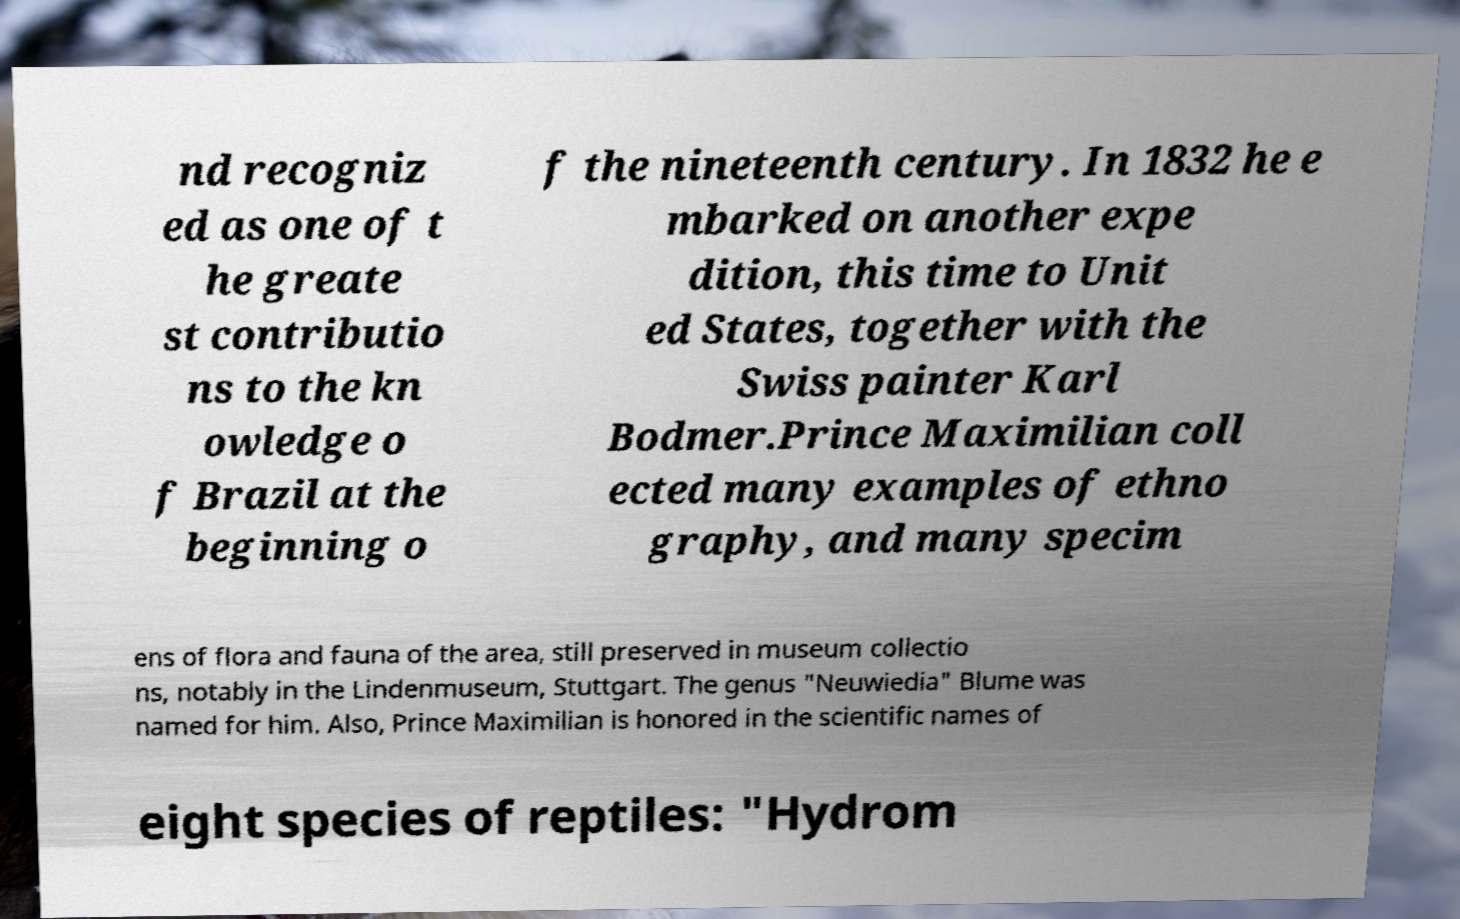There's text embedded in this image that I need extracted. Can you transcribe it verbatim? nd recogniz ed as one of t he greate st contributio ns to the kn owledge o f Brazil at the beginning o f the nineteenth century. In 1832 he e mbarked on another expe dition, this time to Unit ed States, together with the Swiss painter Karl Bodmer.Prince Maximilian coll ected many examples of ethno graphy, and many specim ens of flora and fauna of the area, still preserved in museum collectio ns, notably in the Lindenmuseum, Stuttgart. The genus "Neuwiedia" Blume was named for him. Also, Prince Maximilian is honored in the scientific names of eight species of reptiles: "Hydrom 